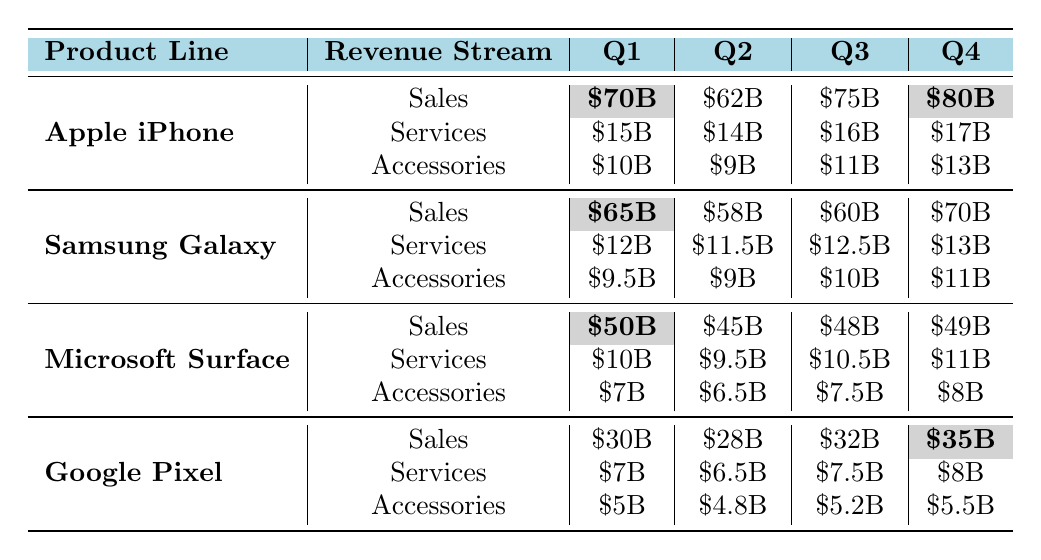What is the total revenue from sales for Apple iPhone in Q4? The revenue from sales for Apple iPhone in Q4 is \$80 billion.
Answer: \$80 billion Which product line has the highest revenue from services in Q4? In Q4, Apple iPhone has \$17 billion in services revenue, which is the highest compared to the other product lines.
Answer: Apple iPhone What is the revenue difference from sales between Q1 and Q3 for Microsoft Surface? The sales revenue for Microsoft Surface in Q1 is \$50 billion, and in Q3 it is \$48 billion. The difference is \$50 billion - \$48 billion = \$2 billion.
Answer: \$2 billion What is the average revenue from accessories for Google Pixel across all quarters? The accessory revenues for Google Pixel are \$5 billion, \$4.8 billion, \$5.2 billion, and \$5.5 billion. The total is \$5 + \$4.8 + \$5.2 + \$5.5 = \$20.5 billion, and the average is \$20.5 billion / 4 = \$5.125 billion.
Answer: \$5.125 billion Is the total revenue from sales for Samsung Galaxy in Q2 greater than the total revenue from services in Q4 for the same product line? In Q2, sales revenue for Samsung Galaxy is \$58 billion, while the services revenue in Q4 is \$13 billion. Since \$58 billion > \$13 billion, the statement is true.
Answer: Yes What is the total revenue from all streams for Apple iPhone in Q1? The total revenue for Apple iPhone in Q1 from all streams is \$70 billion (sales) + \$15 billion (services) + \$10 billion (accessories) = \$95 billion.
Answer: \$95 billion Which product line had the lowest revenue from accessories in Q1, and what was that amount? In Q1, the product line with the lowest revenue from accessories is Microsoft Surface with \$7 billion.
Answer: Microsoft Surface, \$7 billion What is the combined revenue from sales for both Apple iPhone and Samsung Galaxy in Q3? The sales revenue for Apple iPhone in Q3 is \$75 billion and for Samsung Galaxy it's \$60 billion. The combined revenue is \$75 billion + \$60 billion = \$135 billion.
Answer: \$135 billion What was the highest quarterly revenue from services for any product line? The highest quarterly revenue from services is \$17 billion for Apple iPhone in Q4.
Answer: \$17 billion What is the total revenue from services for each product line across all quarters? The total for each is: Apple iPhone: \$15B + \$14B + \$16B + \$17B = \$62B; Samsung Galaxy: \$12B + \$11.5B + \$12.5B + \$13B = \$49B; Microsoft Surface: \$10B + \$9.5B + \$10.5B + \$11B = \$41B; Google Pixel: \$7B + \$6.5B + \$7.5B + \$8B = \$29B.
Answer: Apple iPhone: \$62B, Samsung Galaxy: \$49B, Microsoft Surface: \$41B, Google Pixel: \$29B 